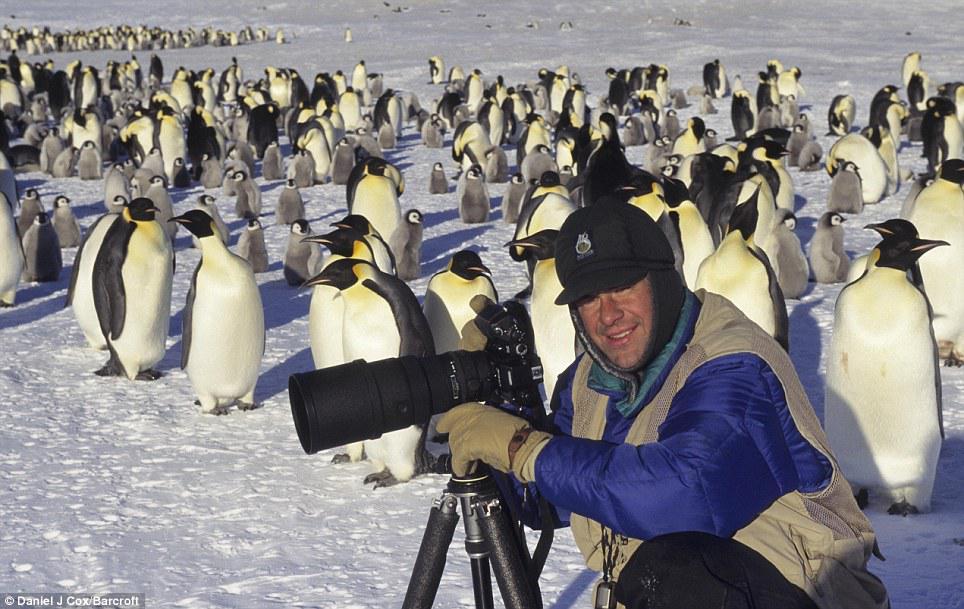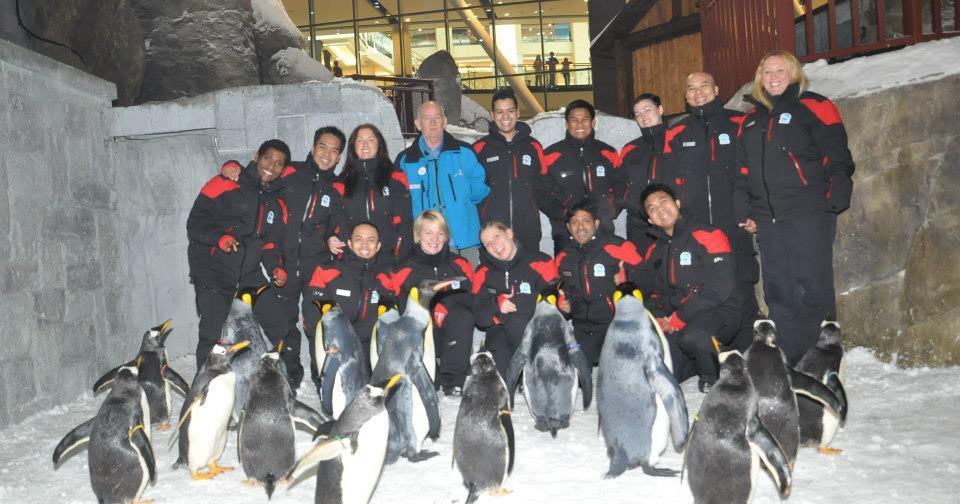The first image is the image on the left, the second image is the image on the right. Analyze the images presented: Is the assertion "One camera is attached to a tripod that's resting on the ground." valid? Answer yes or no. Yes. The first image is the image on the left, the second image is the image on the right. Considering the images on both sides, is "An image includes at least one penguin and a person behind a scope on a tripod." valid? Answer yes or no. Yes. 